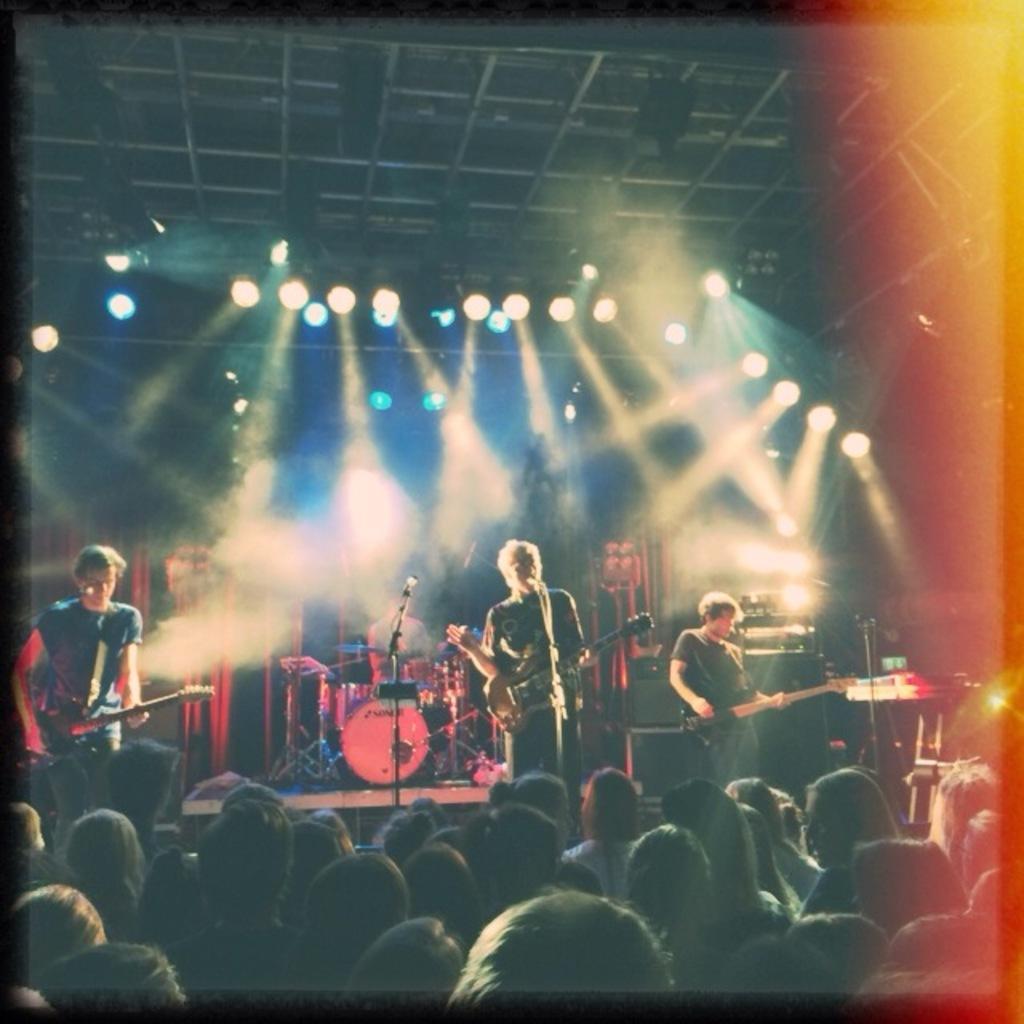Can you describe this image briefly? It looks like a three people who are giving a stage performance. They are holding a guitar in their hand. In the background we can see a lighting arrangement. Here we can see a group of people who are watching these people. 